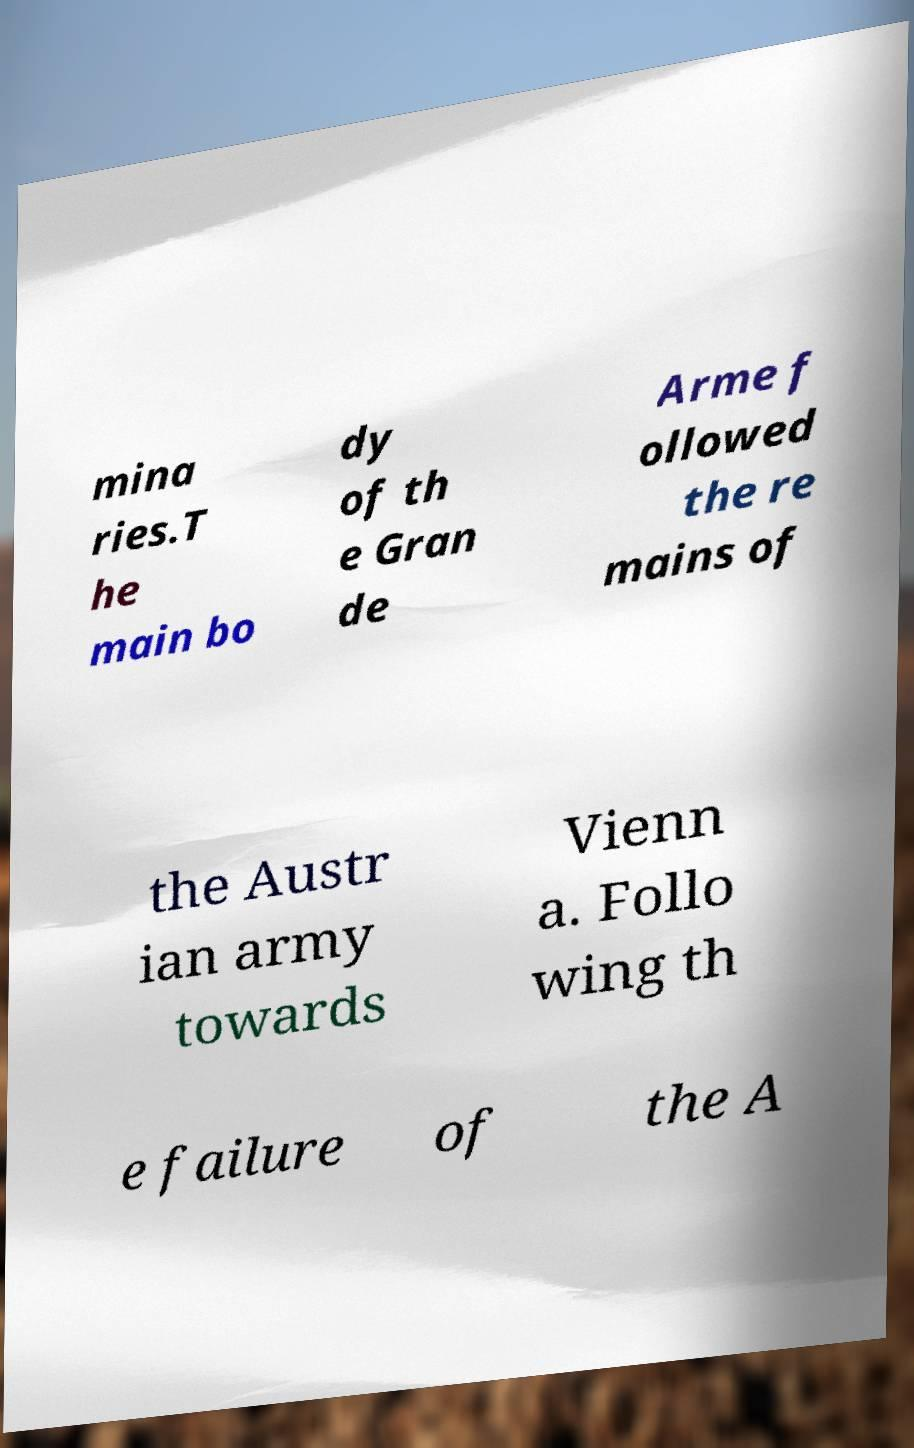Can you accurately transcribe the text from the provided image for me? mina ries.T he main bo dy of th e Gran de Arme f ollowed the re mains of the Austr ian army towards Vienn a. Follo wing th e failure of the A 